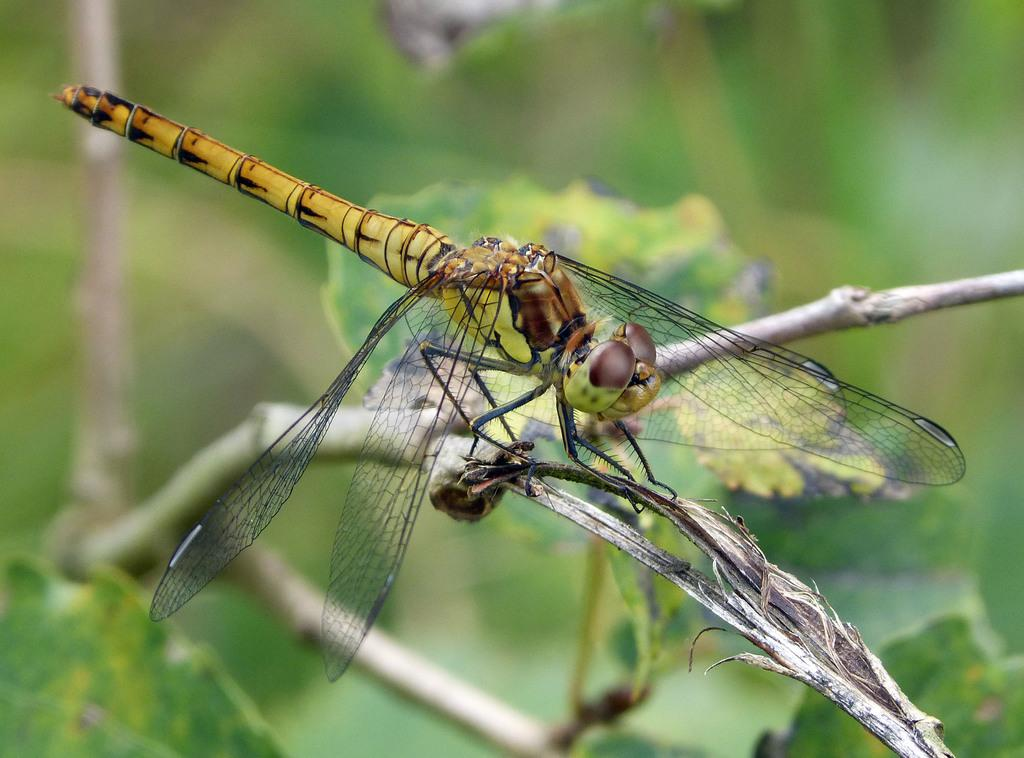What type of creature can be seen in the image? There is an insect in the image. Where is the insect located? The insect is on a tree branch. What can be seen in the background of the image? There are leaves visible in the background of the image. How would you describe the clarity of the image? The image is blurry. What type of army is marching through the image? There is no army present in the image; it features an insect on a tree branch. What color is the skirt worn by the insect in the image? Insects do not wear skirts, and there is no skirt present in the image. 